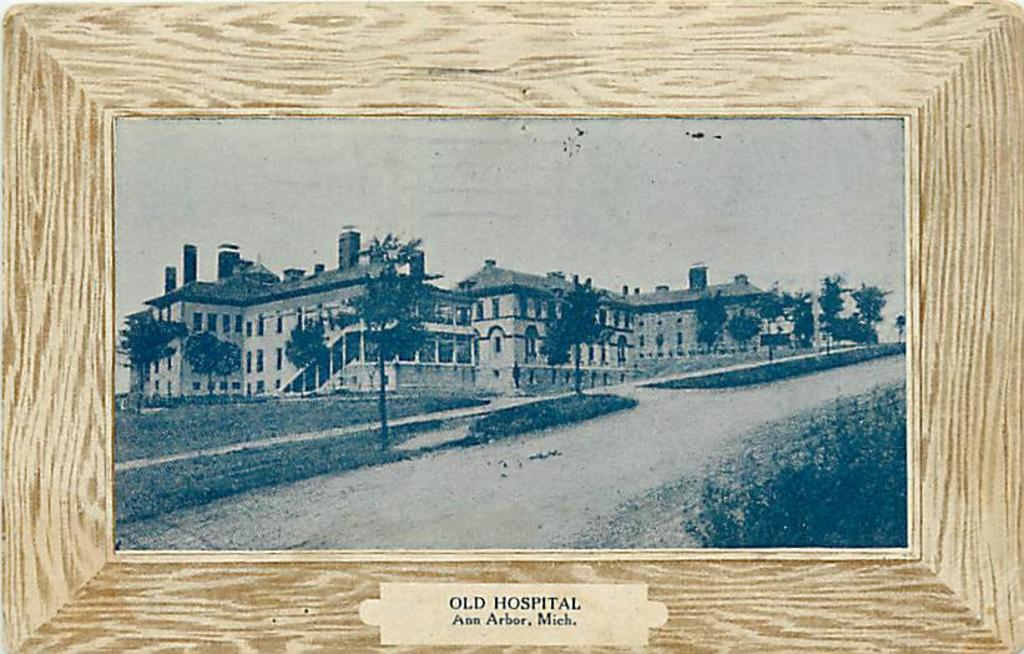Provide a one-sentence caption for the provided image. a frame that has old hospital written on it. 